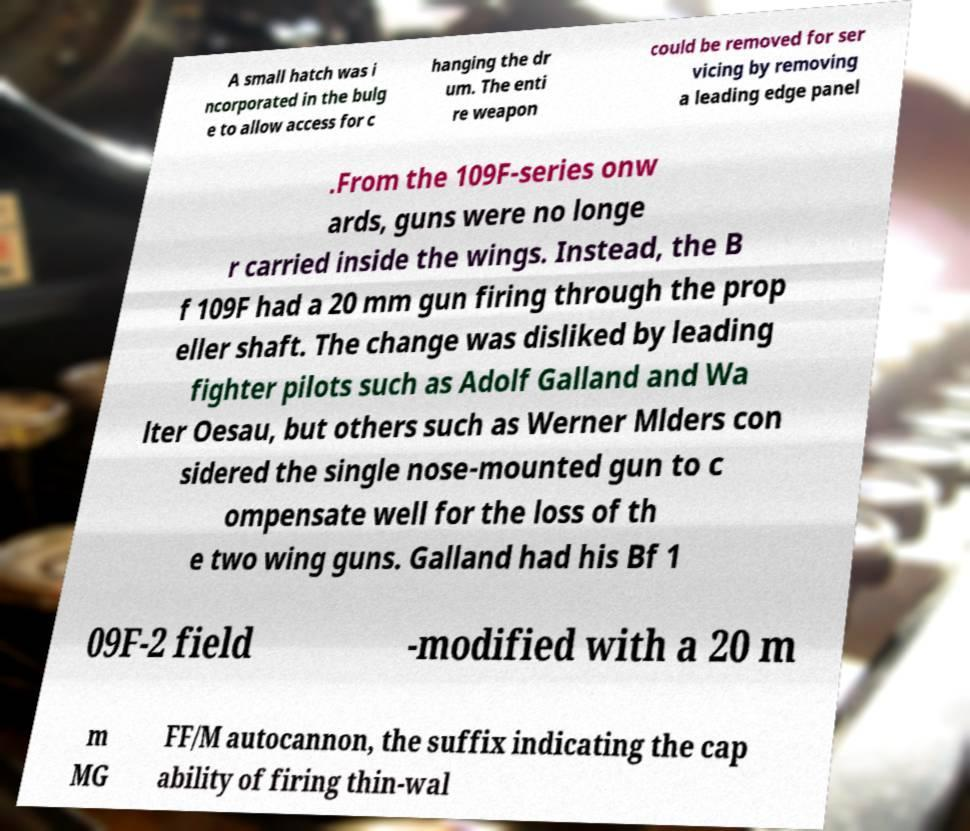There's text embedded in this image that I need extracted. Can you transcribe it verbatim? A small hatch was i ncorporated in the bulg e to allow access for c hanging the dr um. The enti re weapon could be removed for ser vicing by removing a leading edge panel .From the 109F-series onw ards, guns were no longe r carried inside the wings. Instead, the B f 109F had a 20 mm gun firing through the prop eller shaft. The change was disliked by leading fighter pilots such as Adolf Galland and Wa lter Oesau, but others such as Werner Mlders con sidered the single nose-mounted gun to c ompensate well for the loss of th e two wing guns. Galland had his Bf 1 09F-2 field -modified with a 20 m m MG FF/M autocannon, the suffix indicating the cap ability of firing thin-wal 